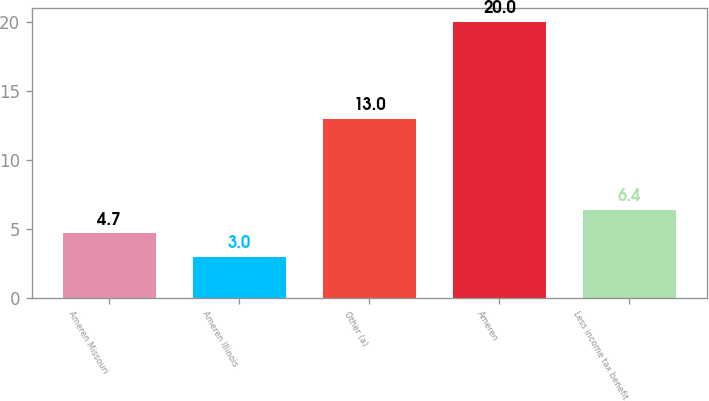<chart> <loc_0><loc_0><loc_500><loc_500><bar_chart><fcel>Ameren Missouri<fcel>Ameren Illinois<fcel>Other (a)<fcel>Ameren<fcel>Less income tax benefit<nl><fcel>4.7<fcel>3<fcel>13<fcel>20<fcel>6.4<nl></chart> 